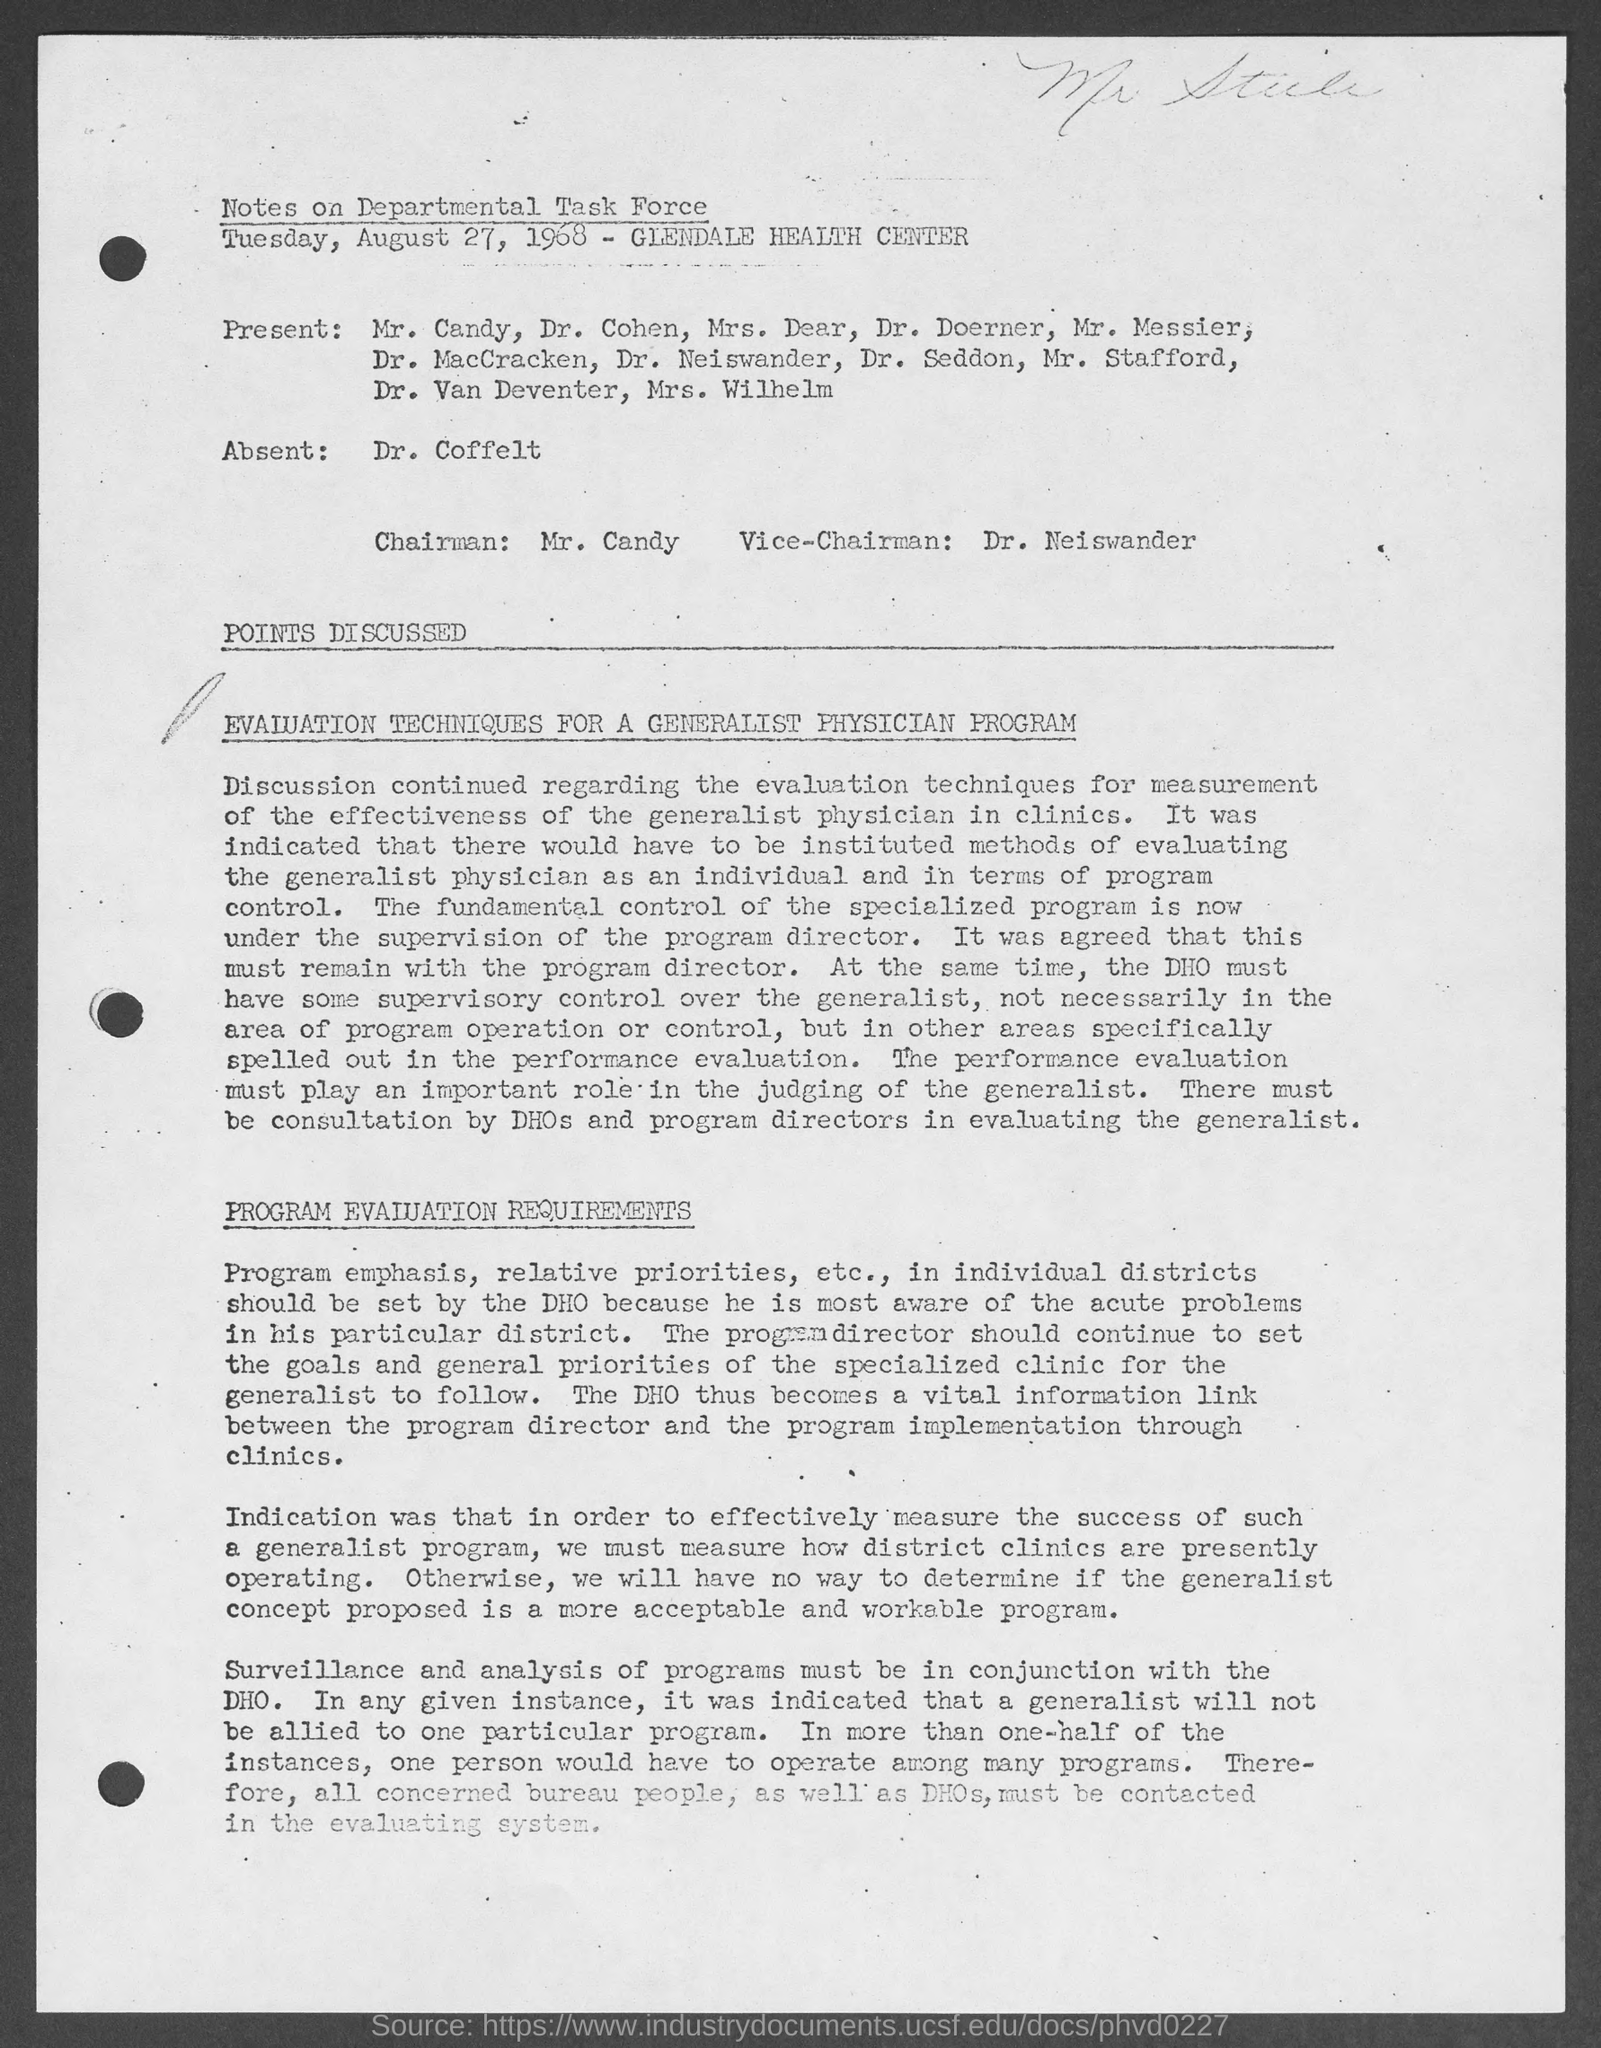Identify some key points in this picture. The Vice-Chairman mentioned in the document is Dr. Neiswander. The document specifies that TUESDAY, AUGUST 27, 1968 was the date mentioned in the document. The Chairman mentioned in the document is Mr. Candy. The Notes on Departmental Task Force indicated that Dr. Coffelt was marked absent. 